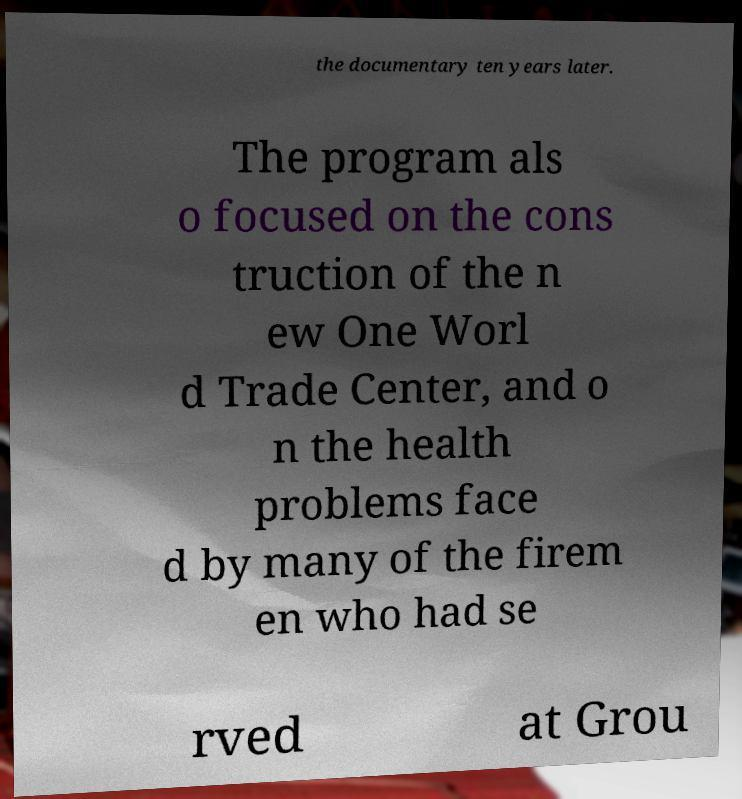There's text embedded in this image that I need extracted. Can you transcribe it verbatim? the documentary ten years later. The program als o focused on the cons truction of the n ew One Worl d Trade Center, and o n the health problems face d by many of the firem en who had se rved at Grou 